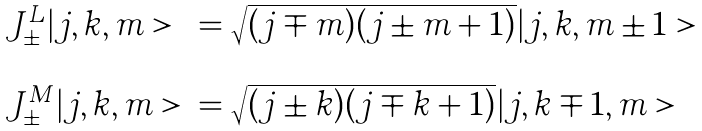Convert formula to latex. <formula><loc_0><loc_0><loc_500><loc_500>\begin{array} { l l } J ^ { L } _ { \pm } | j , k , m > & = \sqrt { ( j \mp m ) ( j \pm m + 1 ) } | j , k , m \pm 1 > \\ & \\ J ^ { M } _ { \pm } | j , k , m > & = \sqrt { ( j \pm k ) ( j \mp k + 1 ) } | j , k \mp 1 , m > \\ \end{array}</formula> 